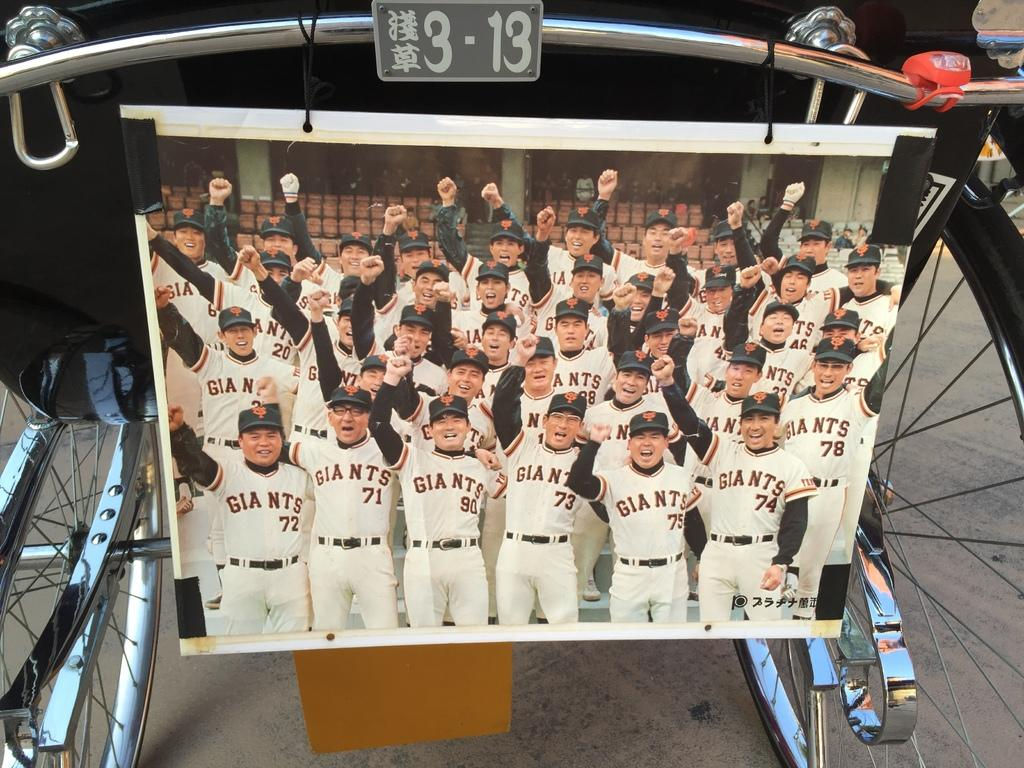<image>
Give a short and clear explanation of the subsequent image. Photo of a group of Giants photos raising their fists. 